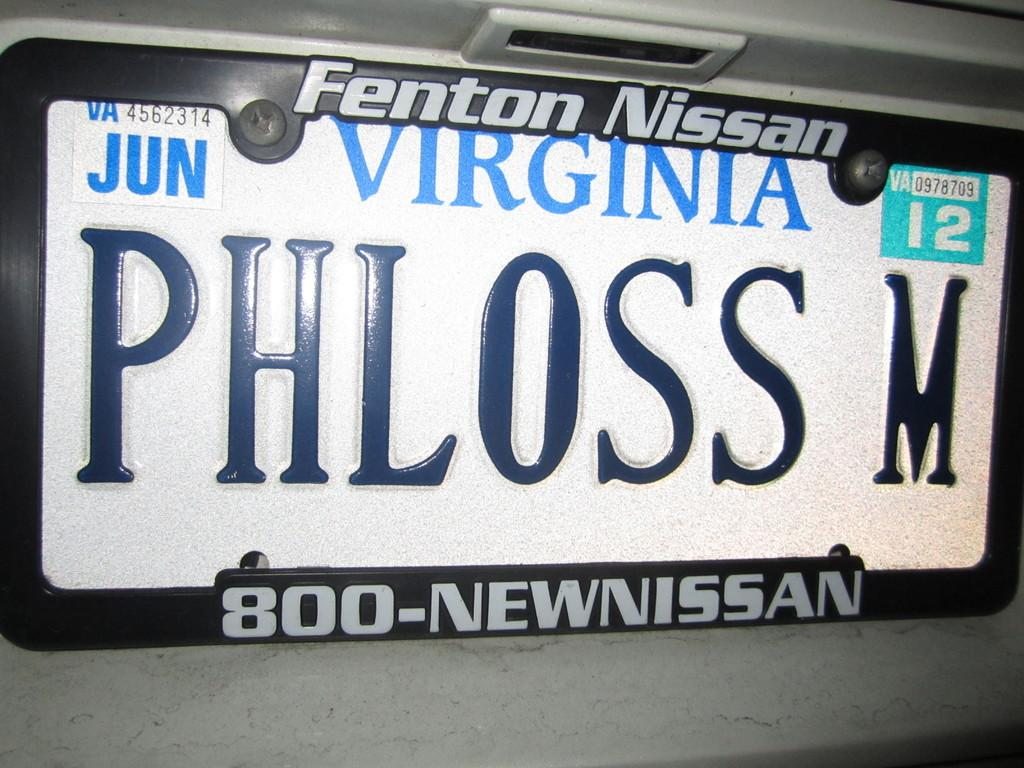<image>
Relay a brief, clear account of the picture shown. A Nissan license plate from Virginia with the writing PHLOSS M. 